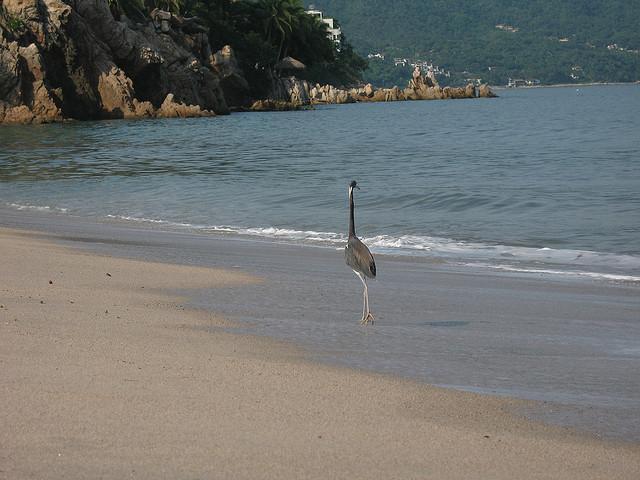How many birds are in the sky?
Give a very brief answer. 0. 